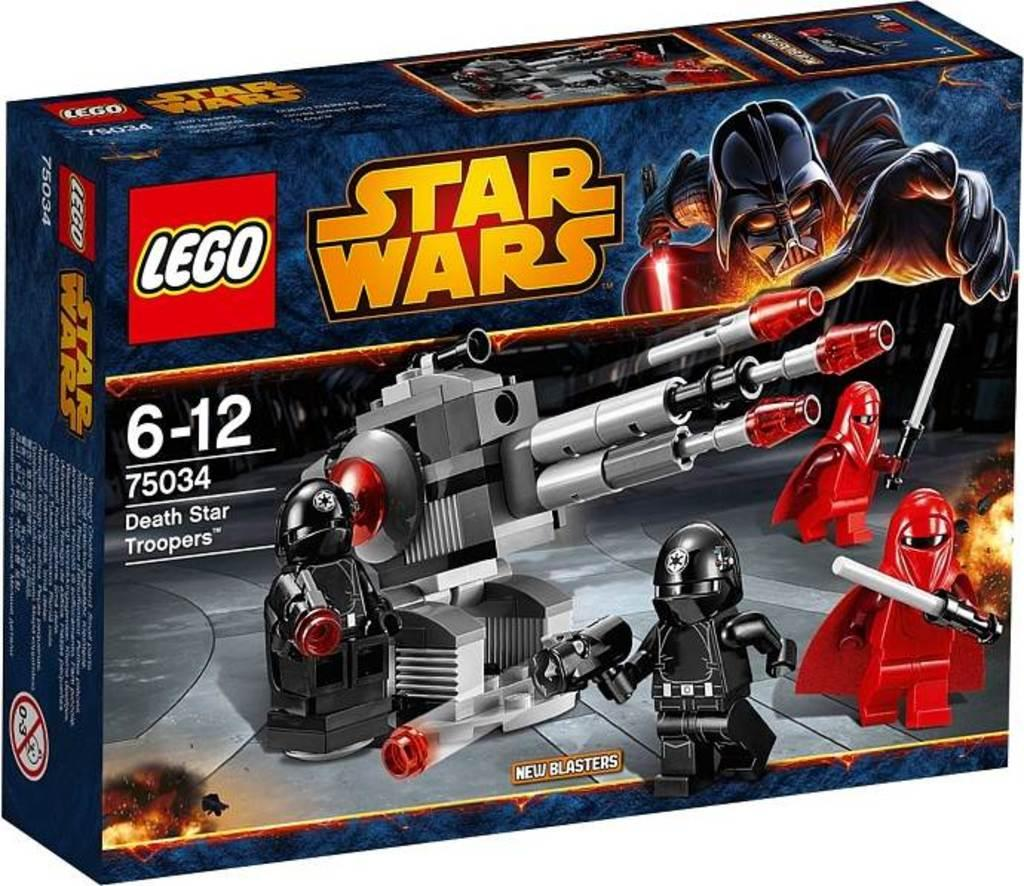<image>
Create a compact narrative representing the image presented. A Star Wars Lego kit that has new blasters. 